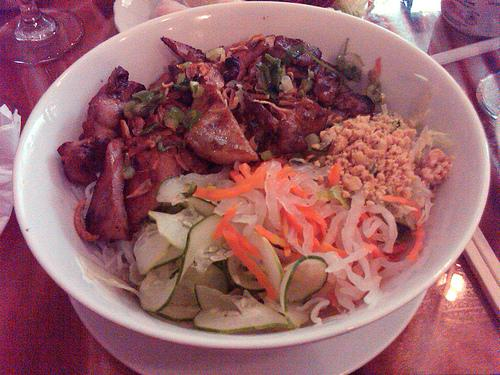Question: where is the bowl?
Choices:
A. On the counter.
B. On the table.
C. On a plate.
D. In the cabinet.
Answer with the letter. Answer: C Question: where is the cucumber?
Choices:
A. On the counter.
B. In the bowl.
C. In the grocery bag.
D. In the refrigerator.
Answer with the letter. Answer: B Question: how many white dishes can you see?
Choices:
A. Three.
B. Two.
C. Six.
D. Eight.
Answer with the letter. Answer: A Question: where is the glass?
Choices:
A. On the table.
B. On the counter.
C. Behind the bowl.
D. On a coaster.
Answer with the letter. Answer: C 